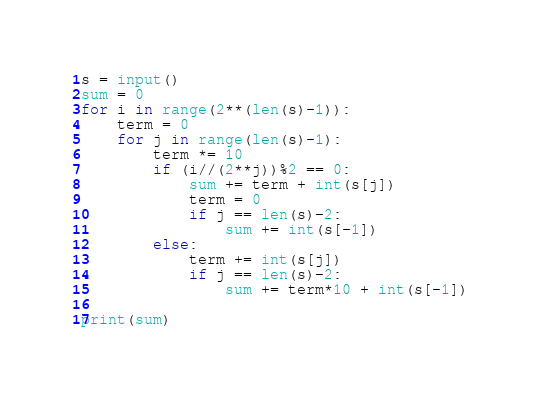Convert code to text. <code><loc_0><loc_0><loc_500><loc_500><_Python_>s = input()
sum = 0
for i in range(2**(len(s)-1)):
    term = 0
    for j in range(len(s)-1):
        term *= 10
        if (i//(2**j))%2 == 0:
            sum += term + int(s[j])
            term = 0
            if j == len(s)-2:
                sum += int(s[-1])
        else:
            term += int(s[j])
            if j == len(s)-2:
                sum += term*10 + int(s[-1])

print(sum)</code> 